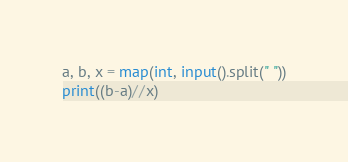Convert code to text. <code><loc_0><loc_0><loc_500><loc_500><_Python_>a, b, x = map(int, input().split(" "))
print((b-a)//x)</code> 